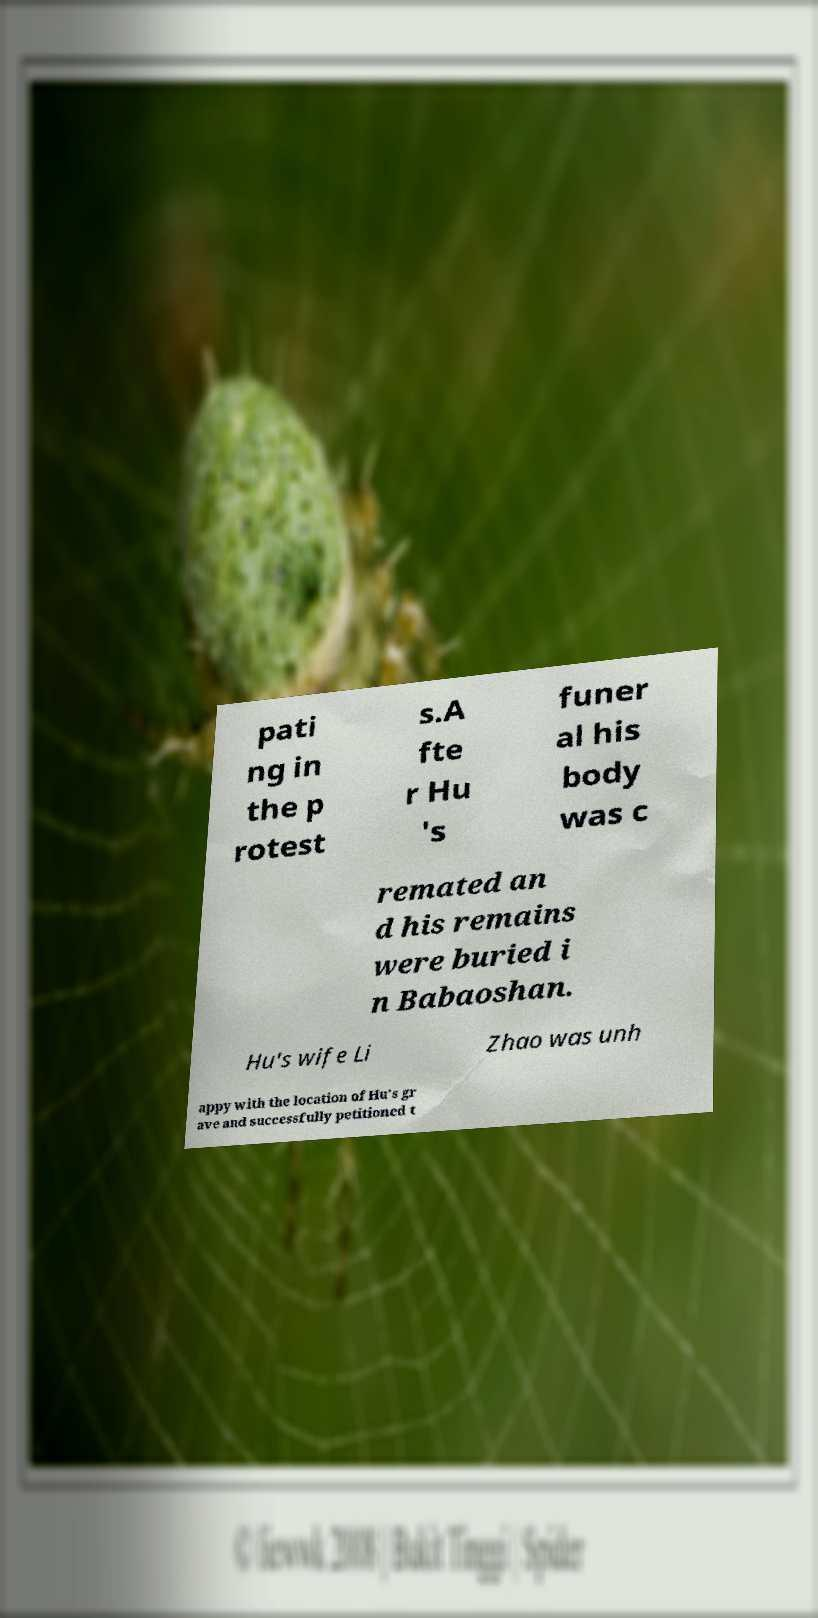Can you read and provide the text displayed in the image?This photo seems to have some interesting text. Can you extract and type it out for me? pati ng in the p rotest s.A fte r Hu 's funer al his body was c remated an d his remains were buried i n Babaoshan. Hu's wife Li Zhao was unh appy with the location of Hu's gr ave and successfully petitioned t 